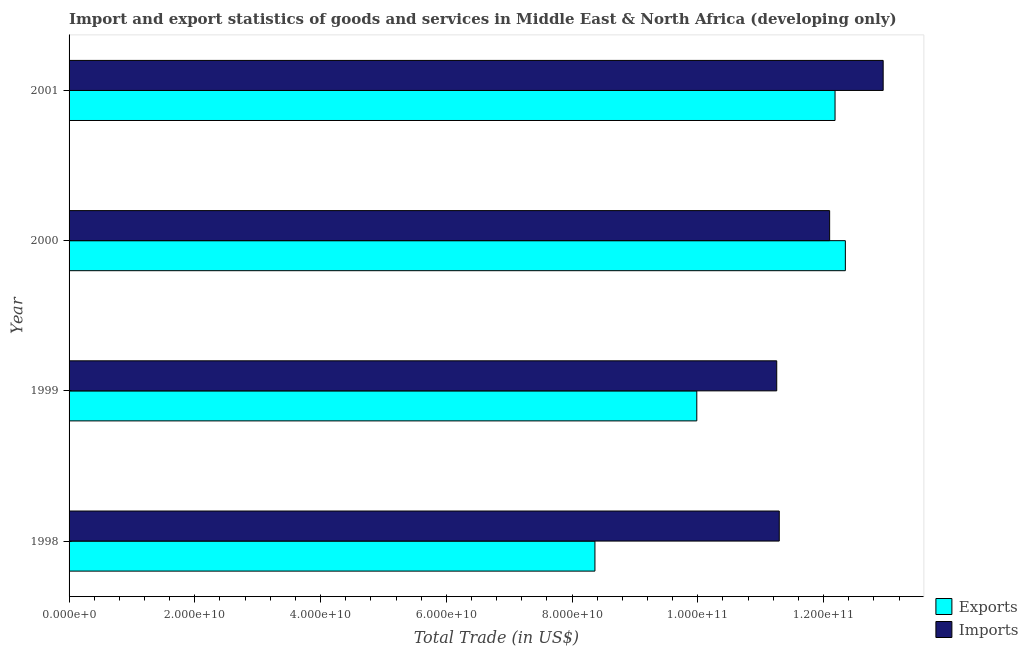How many different coloured bars are there?
Keep it short and to the point. 2. How many groups of bars are there?
Provide a short and direct response. 4. Are the number of bars per tick equal to the number of legend labels?
Give a very brief answer. Yes. How many bars are there on the 1st tick from the bottom?
Your answer should be compact. 2. What is the export of goods and services in 1998?
Provide a succinct answer. 8.36e+1. Across all years, what is the maximum imports of goods and services?
Offer a very short reply. 1.29e+11. Across all years, what is the minimum imports of goods and services?
Your answer should be compact. 1.13e+11. In which year was the export of goods and services maximum?
Your answer should be very brief. 2000. In which year was the export of goods and services minimum?
Your response must be concise. 1998. What is the total export of goods and services in the graph?
Your response must be concise. 4.29e+11. What is the difference between the export of goods and services in 1999 and that in 2001?
Offer a terse response. -2.20e+1. What is the difference between the export of goods and services in 2000 and the imports of goods and services in 1999?
Provide a succinct answer. 1.09e+1. What is the average imports of goods and services per year?
Provide a short and direct response. 1.19e+11. In the year 2000, what is the difference between the imports of goods and services and export of goods and services?
Offer a terse response. -2.50e+09. In how many years, is the imports of goods and services greater than 8000000000 US$?
Ensure brevity in your answer.  4. What is the ratio of the imports of goods and services in 1999 to that in 2001?
Offer a very short reply. 0.87. What is the difference between the highest and the second highest export of goods and services?
Your answer should be compact. 1.64e+09. What is the difference between the highest and the lowest imports of goods and services?
Provide a succinct answer. 1.69e+1. In how many years, is the imports of goods and services greater than the average imports of goods and services taken over all years?
Your answer should be compact. 2. What does the 1st bar from the top in 2000 represents?
Your response must be concise. Imports. What does the 2nd bar from the bottom in 1999 represents?
Offer a very short reply. Imports. What is the difference between two consecutive major ticks on the X-axis?
Ensure brevity in your answer.  2.00e+1. Are the values on the major ticks of X-axis written in scientific E-notation?
Your answer should be compact. Yes. Where does the legend appear in the graph?
Make the answer very short. Bottom right. How are the legend labels stacked?
Offer a very short reply. Vertical. What is the title of the graph?
Offer a terse response. Import and export statistics of goods and services in Middle East & North Africa (developing only). Does "Underweight" appear as one of the legend labels in the graph?
Keep it short and to the point. No. What is the label or title of the X-axis?
Offer a terse response. Total Trade (in US$). What is the label or title of the Y-axis?
Offer a very short reply. Year. What is the Total Trade (in US$) in Exports in 1998?
Offer a terse response. 8.36e+1. What is the Total Trade (in US$) of Imports in 1998?
Make the answer very short. 1.13e+11. What is the Total Trade (in US$) of Exports in 1999?
Make the answer very short. 9.98e+1. What is the Total Trade (in US$) of Imports in 1999?
Give a very brief answer. 1.13e+11. What is the Total Trade (in US$) of Exports in 2000?
Your answer should be compact. 1.23e+11. What is the Total Trade (in US$) in Imports in 2000?
Offer a terse response. 1.21e+11. What is the Total Trade (in US$) of Exports in 2001?
Ensure brevity in your answer.  1.22e+11. What is the Total Trade (in US$) of Imports in 2001?
Your response must be concise. 1.29e+11. Across all years, what is the maximum Total Trade (in US$) in Exports?
Your response must be concise. 1.23e+11. Across all years, what is the maximum Total Trade (in US$) in Imports?
Provide a succinct answer. 1.29e+11. Across all years, what is the minimum Total Trade (in US$) in Exports?
Offer a terse response. 8.36e+1. Across all years, what is the minimum Total Trade (in US$) in Imports?
Keep it short and to the point. 1.13e+11. What is the total Total Trade (in US$) in Exports in the graph?
Your response must be concise. 4.29e+11. What is the total Total Trade (in US$) in Imports in the graph?
Give a very brief answer. 4.76e+11. What is the difference between the Total Trade (in US$) of Exports in 1998 and that in 1999?
Provide a short and direct response. -1.62e+1. What is the difference between the Total Trade (in US$) of Imports in 1998 and that in 1999?
Offer a terse response. 4.03e+08. What is the difference between the Total Trade (in US$) of Exports in 1998 and that in 2000?
Offer a terse response. -3.98e+1. What is the difference between the Total Trade (in US$) of Imports in 1998 and that in 2000?
Offer a very short reply. -8.01e+09. What is the difference between the Total Trade (in US$) in Exports in 1998 and that in 2001?
Offer a very short reply. -3.82e+1. What is the difference between the Total Trade (in US$) of Imports in 1998 and that in 2001?
Offer a very short reply. -1.65e+1. What is the difference between the Total Trade (in US$) of Exports in 1999 and that in 2000?
Give a very brief answer. -2.36e+1. What is the difference between the Total Trade (in US$) in Imports in 1999 and that in 2000?
Offer a very short reply. -8.42e+09. What is the difference between the Total Trade (in US$) in Exports in 1999 and that in 2001?
Your response must be concise. -2.20e+1. What is the difference between the Total Trade (in US$) of Imports in 1999 and that in 2001?
Offer a very short reply. -1.69e+1. What is the difference between the Total Trade (in US$) in Exports in 2000 and that in 2001?
Your answer should be very brief. 1.64e+09. What is the difference between the Total Trade (in US$) of Imports in 2000 and that in 2001?
Your answer should be compact. -8.51e+09. What is the difference between the Total Trade (in US$) of Exports in 1998 and the Total Trade (in US$) of Imports in 1999?
Offer a terse response. -2.89e+1. What is the difference between the Total Trade (in US$) in Exports in 1998 and the Total Trade (in US$) in Imports in 2000?
Give a very brief answer. -3.73e+1. What is the difference between the Total Trade (in US$) in Exports in 1998 and the Total Trade (in US$) in Imports in 2001?
Offer a very short reply. -4.58e+1. What is the difference between the Total Trade (in US$) of Exports in 1999 and the Total Trade (in US$) of Imports in 2000?
Your answer should be very brief. -2.11e+1. What is the difference between the Total Trade (in US$) of Exports in 1999 and the Total Trade (in US$) of Imports in 2001?
Offer a terse response. -2.96e+1. What is the difference between the Total Trade (in US$) of Exports in 2000 and the Total Trade (in US$) of Imports in 2001?
Give a very brief answer. -6.01e+09. What is the average Total Trade (in US$) in Exports per year?
Make the answer very short. 1.07e+11. What is the average Total Trade (in US$) of Imports per year?
Offer a very short reply. 1.19e+11. In the year 1998, what is the difference between the Total Trade (in US$) in Exports and Total Trade (in US$) in Imports?
Your answer should be compact. -2.93e+1. In the year 1999, what is the difference between the Total Trade (in US$) of Exports and Total Trade (in US$) of Imports?
Give a very brief answer. -1.27e+1. In the year 2000, what is the difference between the Total Trade (in US$) in Exports and Total Trade (in US$) in Imports?
Make the answer very short. 2.50e+09. In the year 2001, what is the difference between the Total Trade (in US$) in Exports and Total Trade (in US$) in Imports?
Your response must be concise. -7.65e+09. What is the ratio of the Total Trade (in US$) in Exports in 1998 to that in 1999?
Give a very brief answer. 0.84. What is the ratio of the Total Trade (in US$) in Imports in 1998 to that in 1999?
Provide a succinct answer. 1. What is the ratio of the Total Trade (in US$) of Exports in 1998 to that in 2000?
Provide a short and direct response. 0.68. What is the ratio of the Total Trade (in US$) in Imports in 1998 to that in 2000?
Offer a very short reply. 0.93. What is the ratio of the Total Trade (in US$) in Exports in 1998 to that in 2001?
Give a very brief answer. 0.69. What is the ratio of the Total Trade (in US$) of Imports in 1998 to that in 2001?
Ensure brevity in your answer.  0.87. What is the ratio of the Total Trade (in US$) of Exports in 1999 to that in 2000?
Ensure brevity in your answer.  0.81. What is the ratio of the Total Trade (in US$) in Imports in 1999 to that in 2000?
Provide a short and direct response. 0.93. What is the ratio of the Total Trade (in US$) of Exports in 1999 to that in 2001?
Provide a succinct answer. 0.82. What is the ratio of the Total Trade (in US$) in Imports in 1999 to that in 2001?
Ensure brevity in your answer.  0.87. What is the ratio of the Total Trade (in US$) of Exports in 2000 to that in 2001?
Give a very brief answer. 1.01. What is the ratio of the Total Trade (in US$) of Imports in 2000 to that in 2001?
Give a very brief answer. 0.93. What is the difference between the highest and the second highest Total Trade (in US$) of Exports?
Ensure brevity in your answer.  1.64e+09. What is the difference between the highest and the second highest Total Trade (in US$) of Imports?
Make the answer very short. 8.51e+09. What is the difference between the highest and the lowest Total Trade (in US$) of Exports?
Provide a succinct answer. 3.98e+1. What is the difference between the highest and the lowest Total Trade (in US$) in Imports?
Offer a terse response. 1.69e+1. 